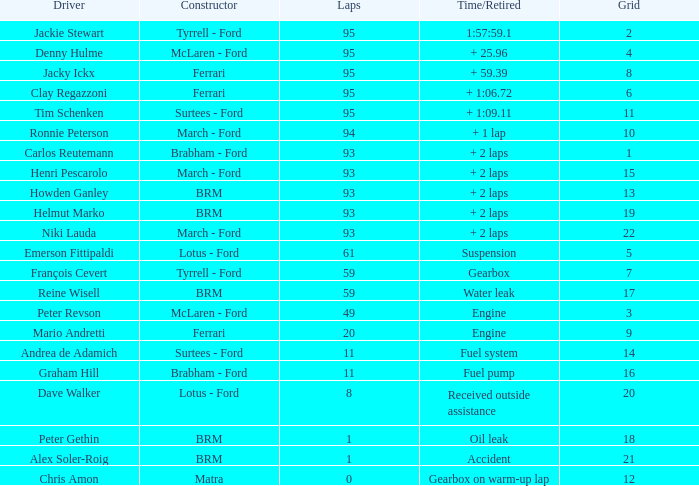How many grids are owned by dave walker? 1.0. 